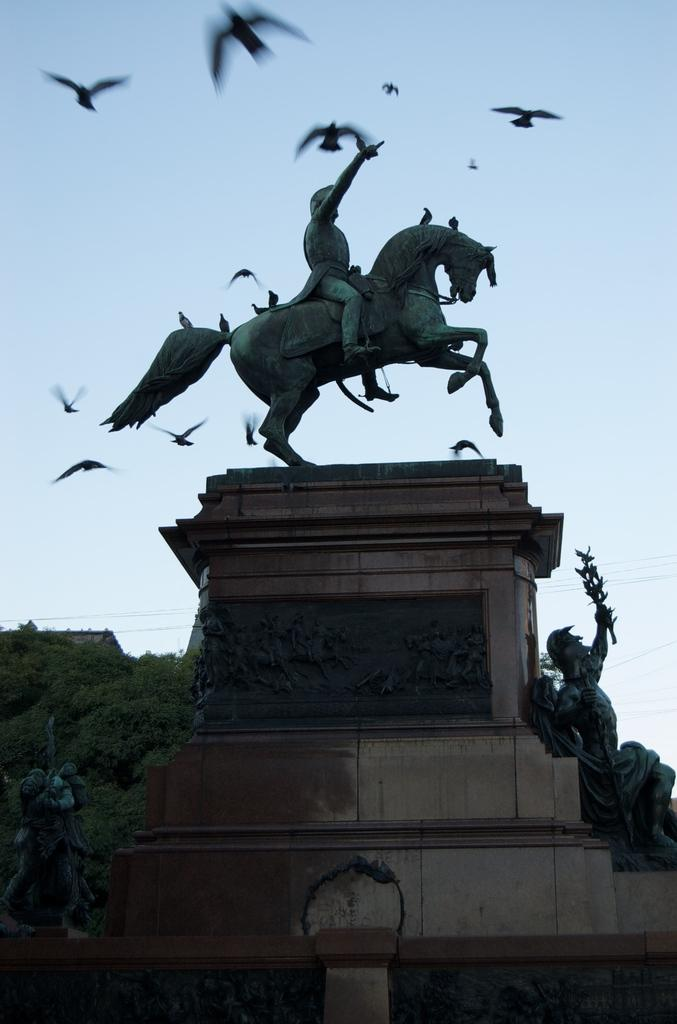What type of objects can be seen in the image? There are statues in the image. What are the statues standing on? There are pedestals in the image. What is happening in the sky in the image? Birds are flying in the air in the image. What type of vegetation is present in the image? There are trees in the image. What is visible in the background of the image? The sky is visible in the image. What type of substance is the statue made of in the image? The provided facts do not mention the material of the statues, so we cannot determine the substance they are made of from the image. 